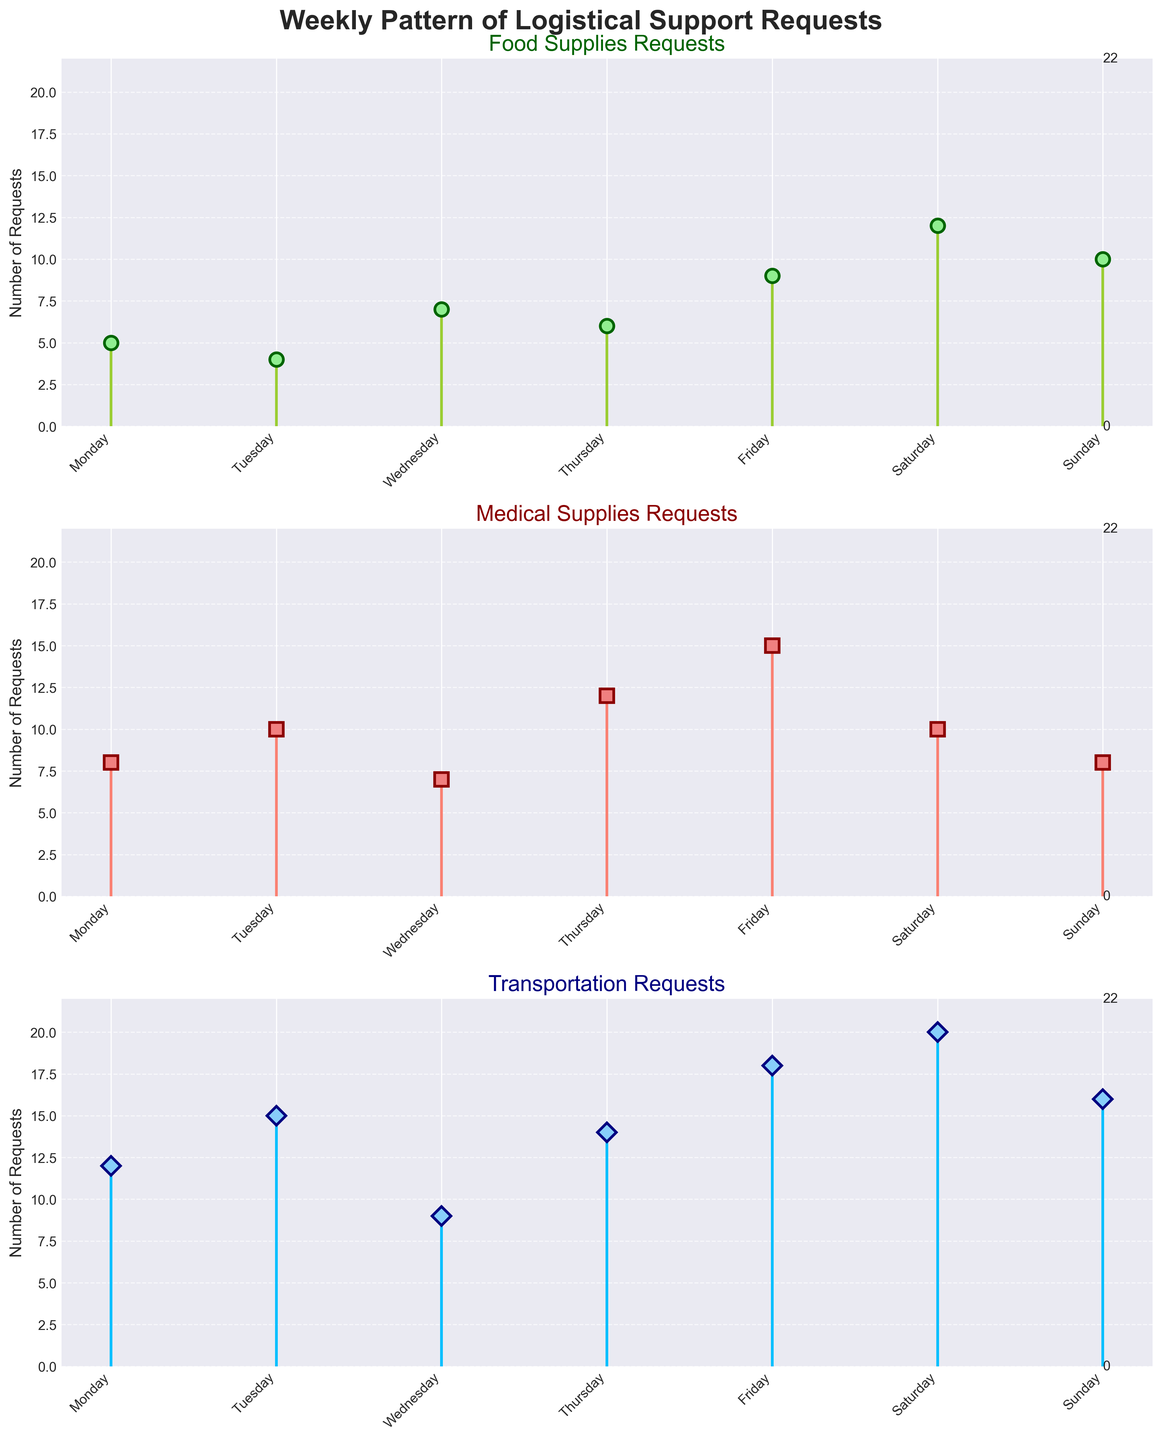What's the color of the stem lines for Food Supplies Requests? The color of the stem lines for Food Supplies Requests is 'yellowgreen', which is a type of green.
Answer: yellowgreen Which day has the highest number of Transportation Requests? To determine the day with the highest number of Transportation Requests, we look at the stem lines in the 'Transportation Requests' subplot. The highest stem is on Saturday with a value of 20.
Answer: Saturday What day has the lowest number of Food Supplies Requests, and how many requests were there? To find the day with the lowest number of Food Supplies Requests, check the smallest stem in the 'Food Supplies Requests' subplot. The lowest stem is on Tuesday with 4 requests.
Answer: Tuesday, 4 What is the total number of requests for Medical Supplies on Monday and Wednesday? Add the number of Medical Supplies Requests on Monday and Wednesday: 8 (Monday) + 7 (Wednesday) equals 15.
Answer: 15 What is the difference in Transportation Requests between Saturday and Wednesday? Subtract the number of Transportation Requests on Wednesday from those on Saturday: 20 (Saturday) - 9 (Wednesday) equals 11.
Answer: 11 Which type of logistical support has the highest request on Friday? Compare the heights of the stems for Food, Medical, and Transportation requests on Friday. The highest stem is for Transportation Requests with a value of 18.
Answer: Transportation Requests How many days have more than 10 Food Supplies Requests? Count the number of days with Food Supplies Requests greater than 10 from the 'Food Supplies Requests' subplot. Only Saturday (12) and Sunday (10) meet this criterion.
Answer: 2 What's the average number of Medical Supplies Requests throughout the week? Sum all Medical Supplies Requests (8 + 10 + 7 + 12 + 15 + 10 + 8 = 70), then divide by the number of days (7): 70 / 7 = 10.
Answer: 10 Which type of logistical support has the most requests in total throughout the week? Sum the requests for each type of logistical support: Food Supplies (5 + 4 + 7 + 6 + 9 + 12 + 10 = 53), Medical Supplies (8 + 10 + 7 + 12 + 15 + 10 + 8 = 70), Transportation (12 + 15 + 9 + 14 + 18 + 20 + 16 = 104). Transportation Requests have the highest total.
Answer: Transportation Requests 